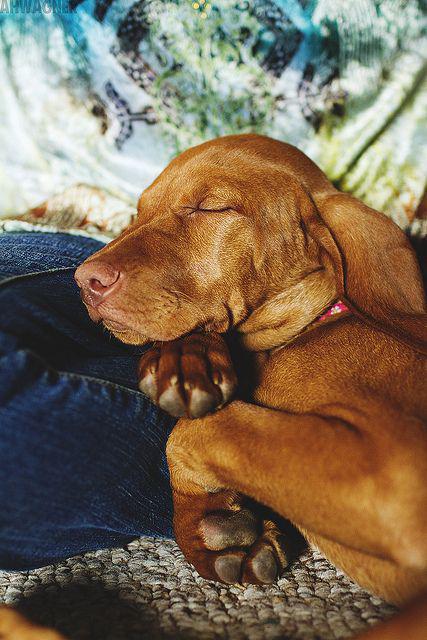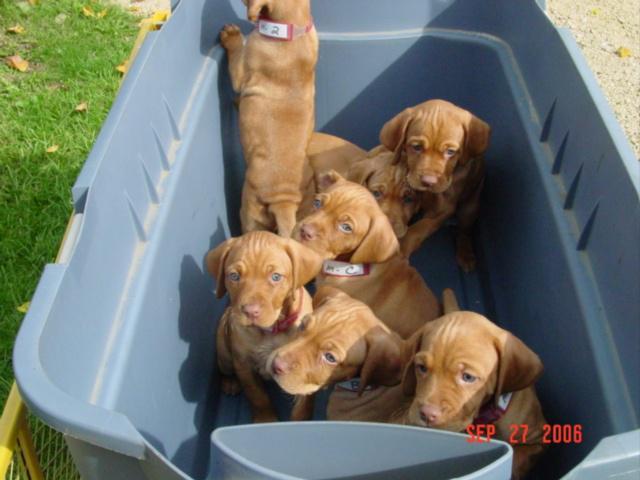The first image is the image on the left, the second image is the image on the right. Analyze the images presented: Is the assertion "One image shows a container holding seven red-orange puppies, and the other image shows one sleeping adult dog." valid? Answer yes or no. Yes. The first image is the image on the left, the second image is the image on the right. Examine the images to the left and right. Is the description "There are more than three puppies sleeping in the image." accurate? Answer yes or no. No. 